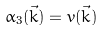<formula> <loc_0><loc_0><loc_500><loc_500>\alpha _ { 3 } ( \vec { k } ) = v ( \vec { k } )</formula> 